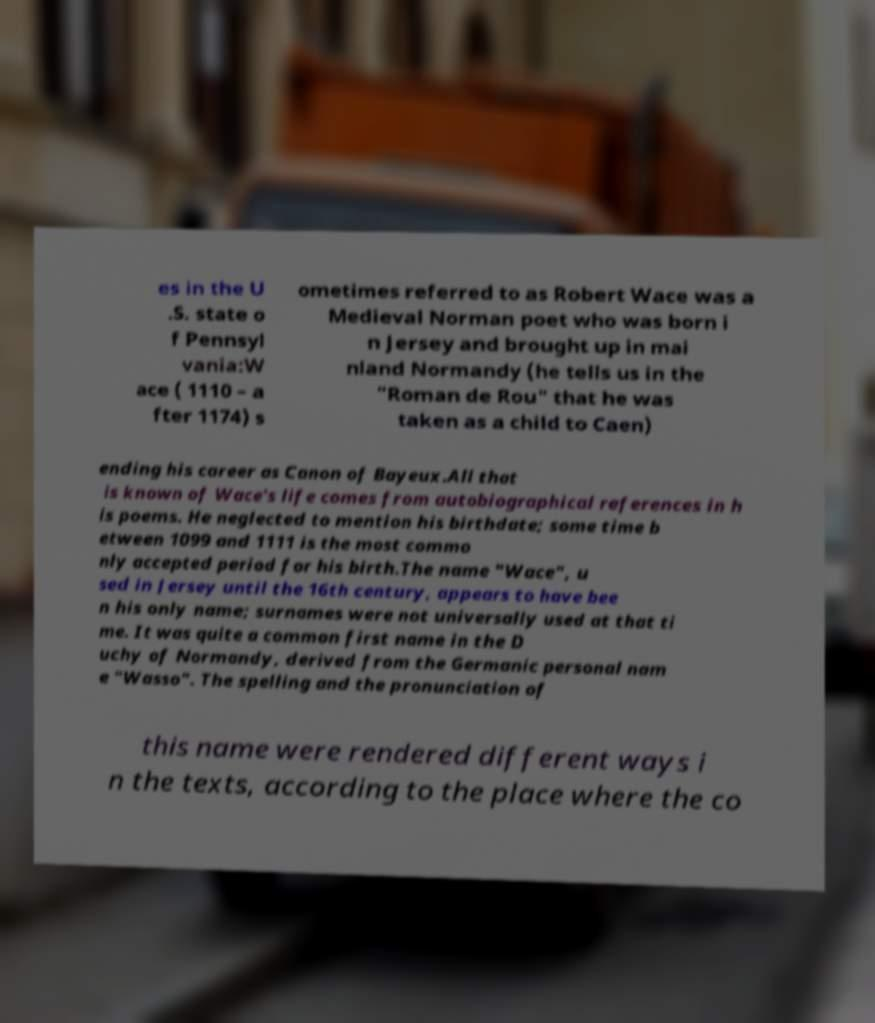Can you read and provide the text displayed in the image?This photo seems to have some interesting text. Can you extract and type it out for me? es in the U .S. state o f Pennsyl vania:W ace ( 1110 – a fter 1174) s ometimes referred to as Robert Wace was a Medieval Norman poet who was born i n Jersey and brought up in mai nland Normandy (he tells us in the "Roman de Rou" that he was taken as a child to Caen) ending his career as Canon of Bayeux.All that is known of Wace's life comes from autobiographical references in h is poems. He neglected to mention his birthdate; some time b etween 1099 and 1111 is the most commo nly accepted period for his birth.The name "Wace", u sed in Jersey until the 16th century, appears to have bee n his only name; surnames were not universally used at that ti me. It was quite a common first name in the D uchy of Normandy, derived from the Germanic personal nam e "Wasso". The spelling and the pronunciation of this name were rendered different ways i n the texts, according to the place where the co 